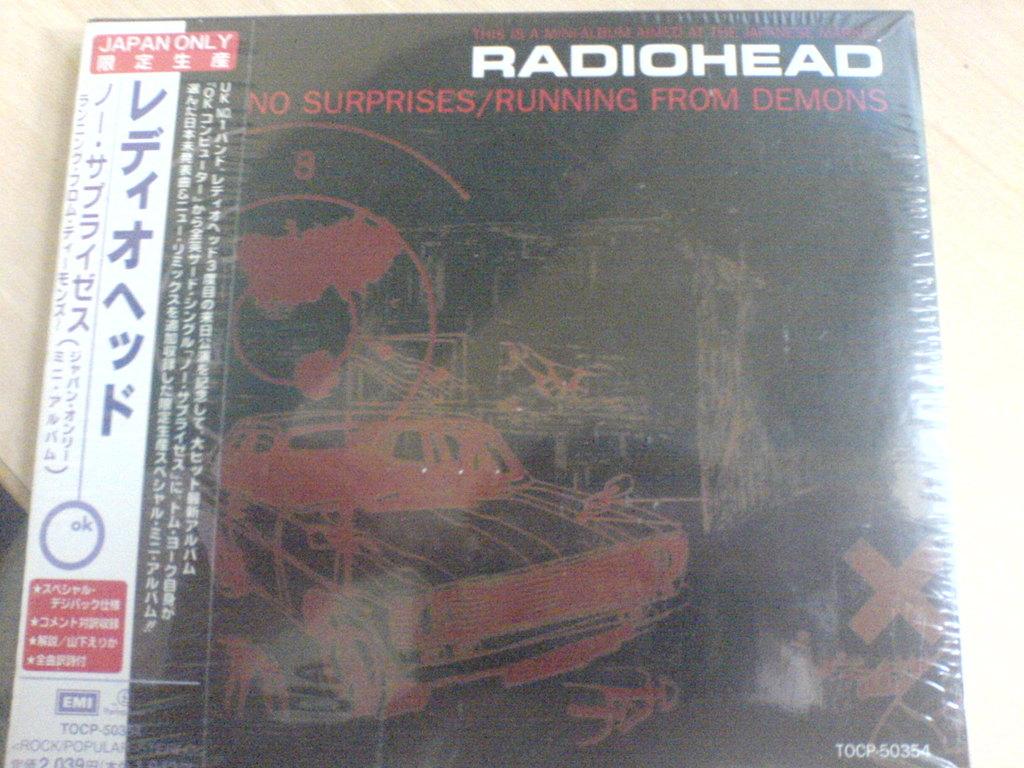What is the name of the band on the top right?
Your answer should be very brief. Radiohead. What is the name of the album?
Make the answer very short. No surprises/running from demons. 